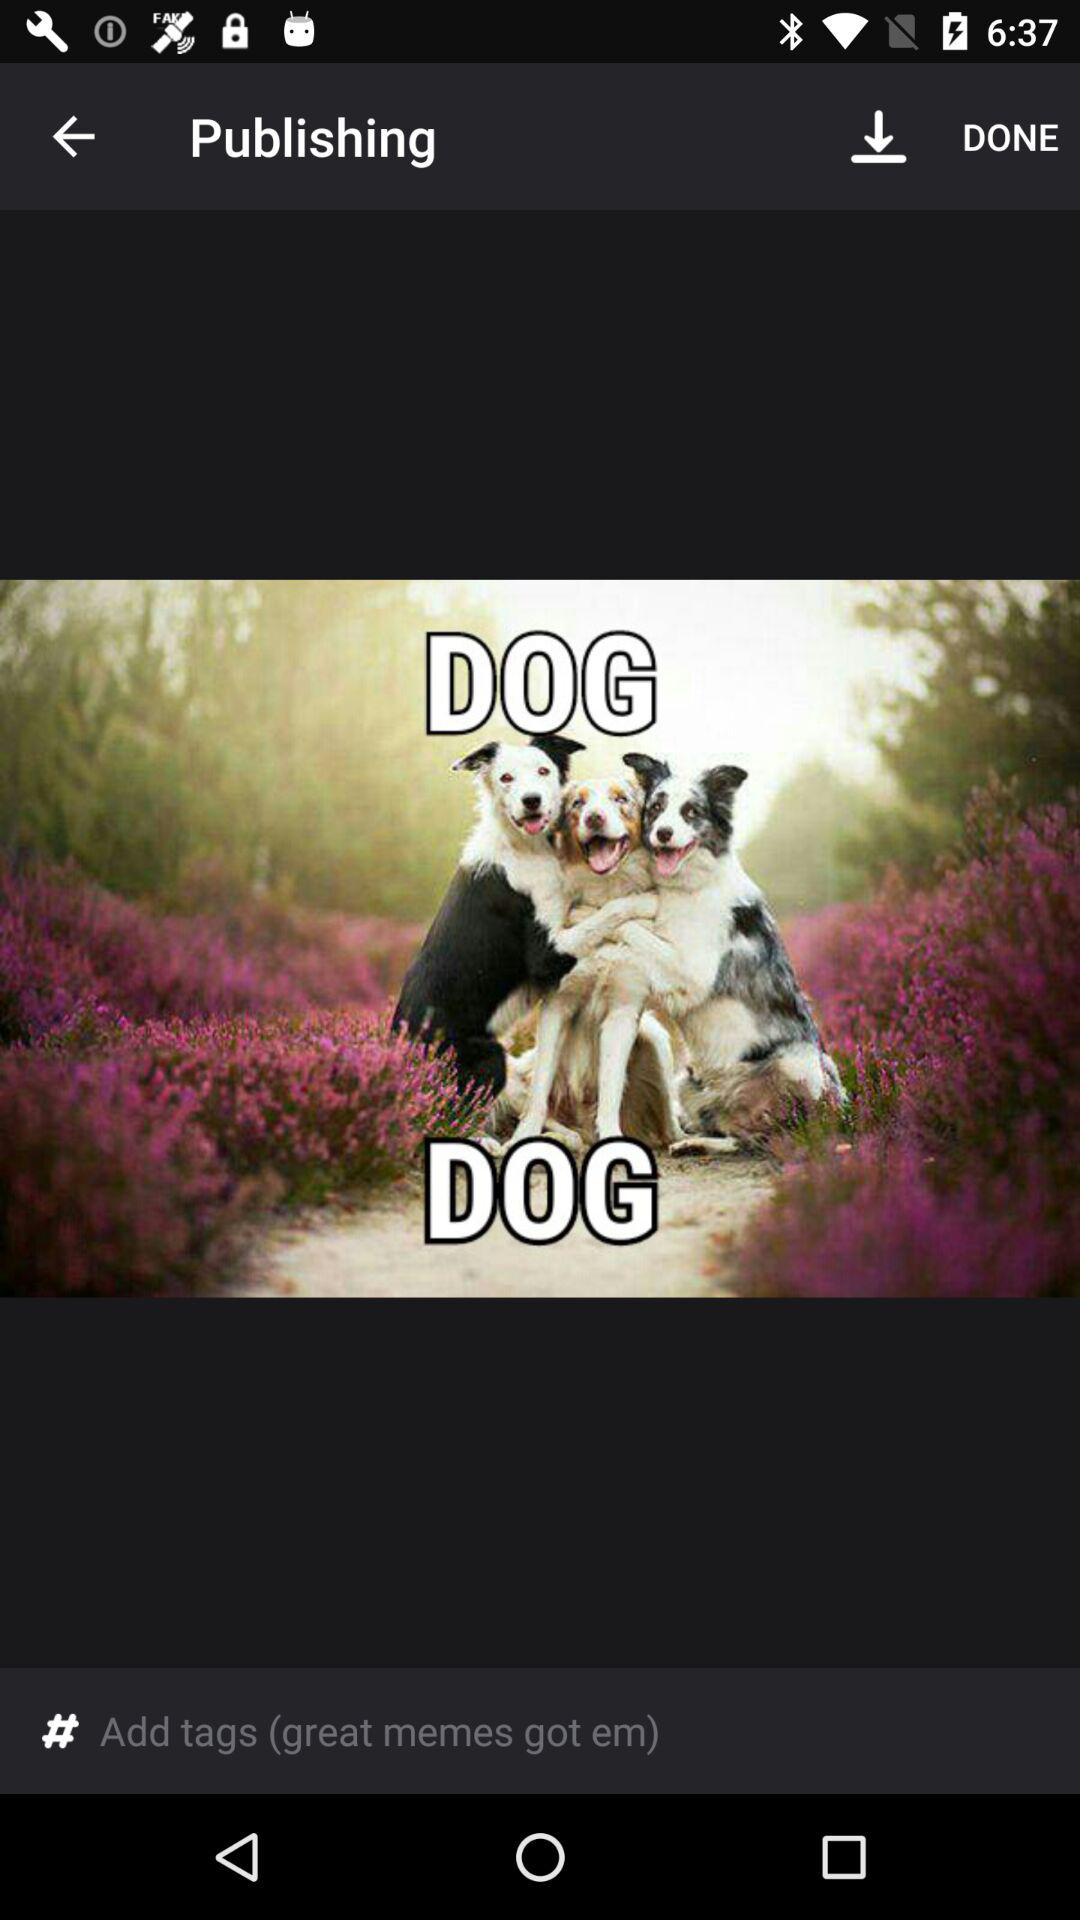How many dogs are in the picture?
Answer the question using a single word or phrase. 3 